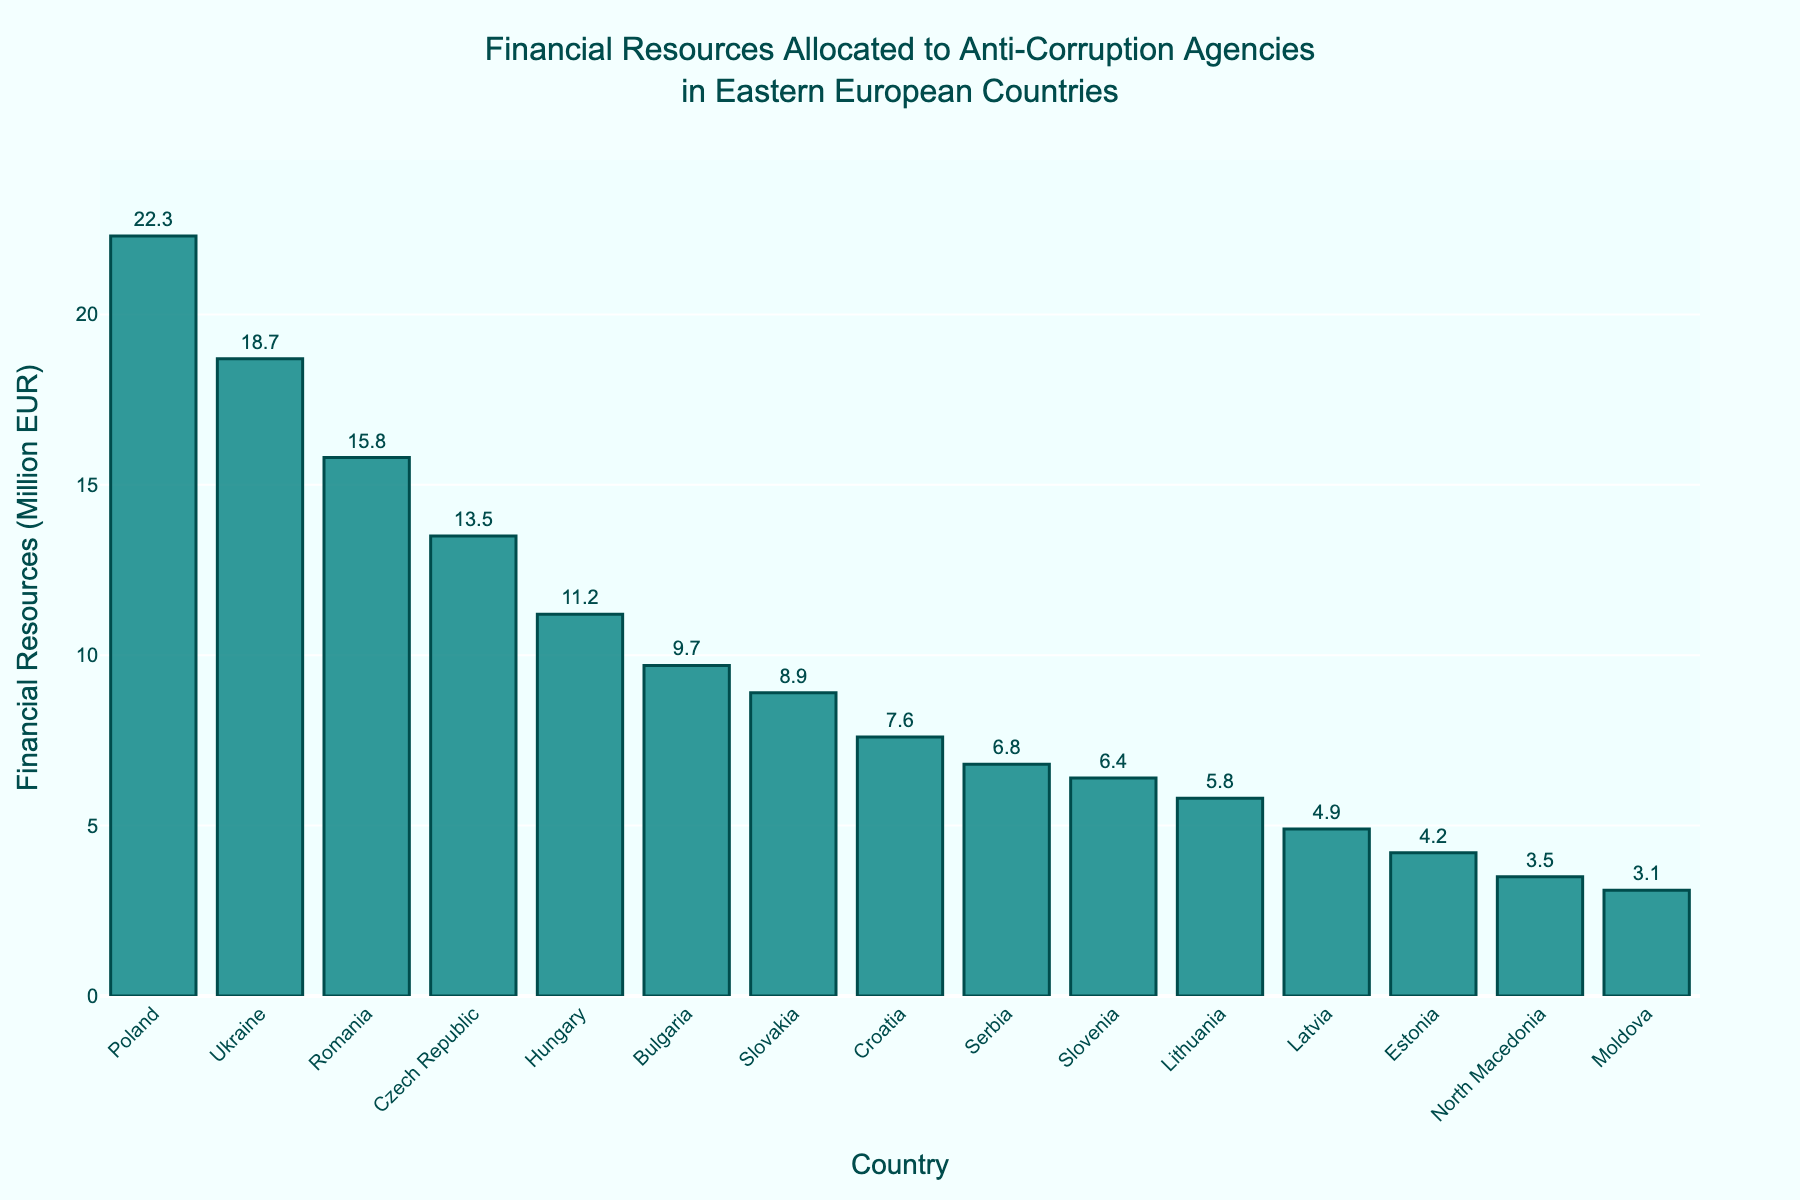Which country allocates the most financial resources to anti-corruption agencies? To answer this, look for the tallest bar in the chart. The bar for Poland is the tallest, indicating that Poland allocates the most financial resources.
Answer: Poland How much more does Poland allocate compared to Bulgaria? First, find the values for Poland and Bulgaria from the chart, which are 22.3 million EUR and 9.7 million EUR respectively. Subtract the Bulgarian allocation from the Polish allocation: 22.3 - 9.7 = 12.6 million EUR.
Answer: 12.6 million EUR Which three countries allocate the least financial resources? Look for the three shortest bars in the chart. The countries with the shortest bars are Moldova, North Macedonia, and Estonia.
Answer: Moldova, North Macedonia, Estonia What is the average financial resource allocation across all countries? Sum up all the values from the chart and divide by the number of countries (15). The sum is 145.4 million EUR. Divide this by 15 to get the average: 145.4 / 15 = 9.69 million EUR.
Answer: 9.69 million EUR What is the combined allocation of Romania and Ukraine? Find the values for both Romania and Ukraine, which are 15.8 million EUR and 18.7 million EUR respectively. Add these values together: 15.8 + 18.7 = 34.5 million EUR.
Answer: 34.5 million EUR How does the allocation of Hungary compare to Croatia? Find the values for Hungary and Croatia, which are 11.2 million EUR and 7.6 million EUR respectively. Compare these values: 11.2 is greater than 7.6.
Answer: Hungary allocates more Which country has a financial resource allocation closest to the median of the dataset? Sort the values from all countries and find the median. The sorted values are: 3.1, 3.5, 4.2, 4.9, 5.8, 6.4, 6.8, 7.6, 8.9, 9.7, 11.2, 13.5, 15.8, 18.7, 22.3. The median is the 8th value: 7.6. Croatia has the value closest to the median.
Answer: Croatia What percentage of the total financial resources is allocated by Ukraine? Find the value for Ukraine, which is 18.7 million EUR. Sum the total allocations (145.4 million EUR). Divide Ukraine's allocation by the total and multiply by 100 for the percentage: (18.7 / 145.4) * 100 ≈ 12.86%.
Answer: 12.86% Is the allocation of Romania greater than the average allocation? The average allocation is 9.69 million EUR and Romania's allocation is 15.8 million EUR. Since 15.8 is greater than 9.69, Romania's allocation is indeed greater than the average.
Answer: Yes 